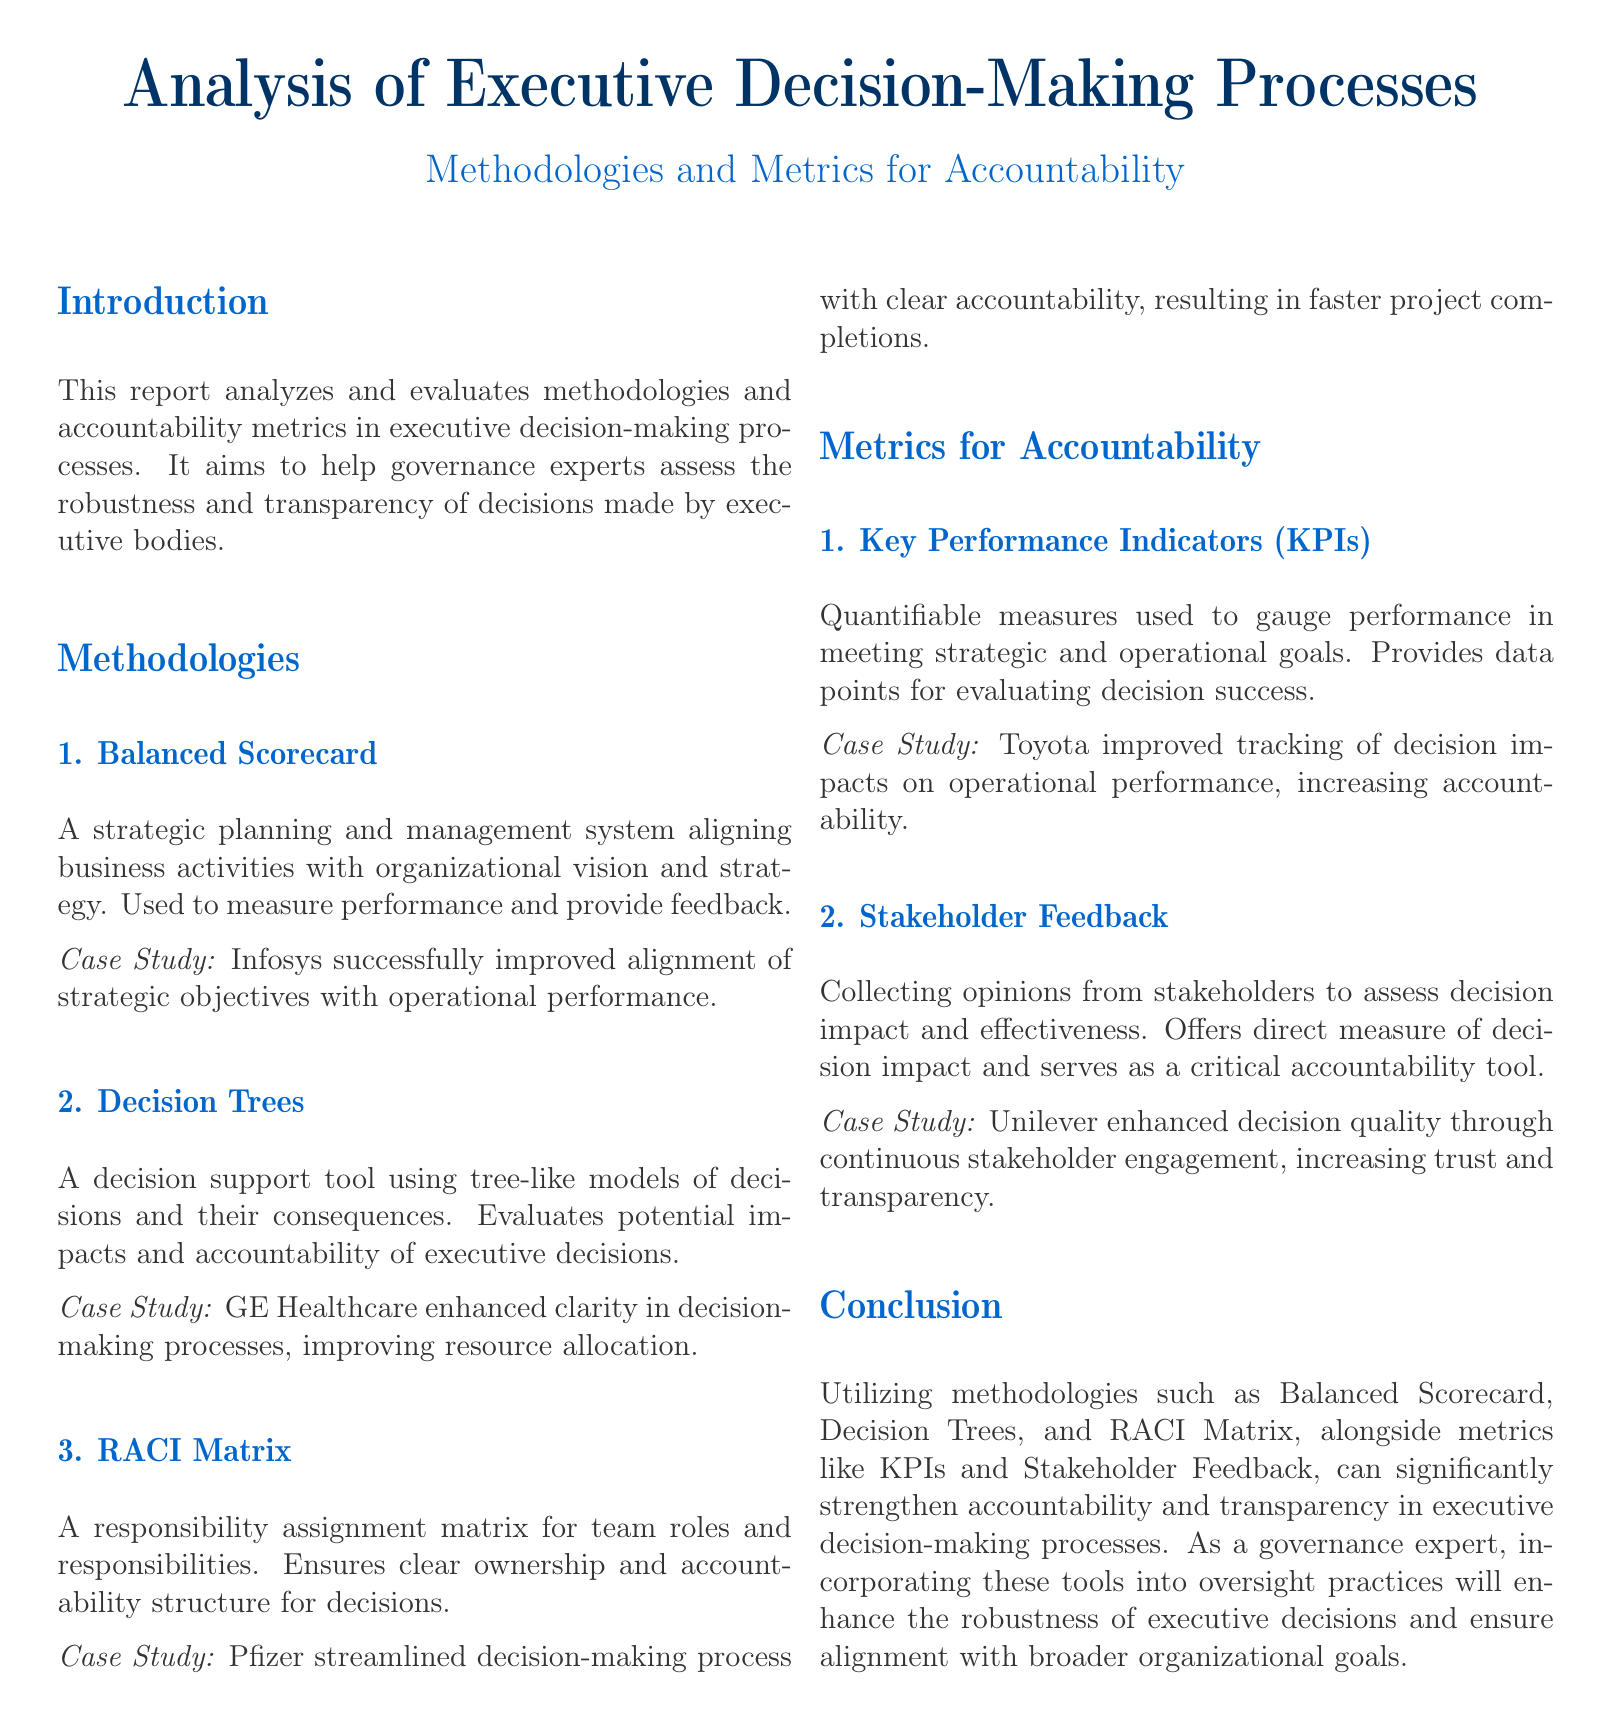What is the focus of this report? The report focuses on analyzing and evaluating methodologies and accountability metrics in executive decision-making processes.
Answer: executive decision-making processes What methodology uses a tree-like model for decision support? The methodology that uses a tree-like model is known as Decision Trees.
Answer: Decision Trees Which company used the Balanced Scorecard methodology? Infosys is the company that successfully used the Balanced Scorecard methodology.
Answer: Infosys What do KPIs stand for? KPIs stand for Key Performance Indicators.
Answer: Key Performance Indicators Which case study illustrates the use of the RACI Matrix? The case study illustrating the use of the RACI Matrix is from Pfizer.
Answer: Pfizer What is a key outcome of using Stakeholder Feedback? A key outcome of using Stakeholder Feedback is increasing trust and transparency.
Answer: increasing trust and transparency How many methodologies are discussed in the report? The report discusses three methodologies.
Answer: three Which metric offers a direct measure of decision impact? Stakeholder Feedback offers a direct measure of decision impact.
Answer: Stakeholder Feedback What is the primary purpose of the Balanced Scorecard? The primary purpose of the Balanced Scorecard is to align business activities with organizational vision and strategy.
Answer: align business activities with organizational vision and strategy 